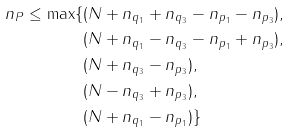Convert formula to latex. <formula><loc_0><loc_0><loc_500><loc_500>n _ { P } \leq \max \{ & ( N + n _ { q _ { 1 } } + n _ { q _ { 3 } } - n _ { p _ { 1 } } - n _ { p _ { 3 } } ) , \\ & ( N + n _ { q _ { 1 } } - n _ { q _ { 3 } } - n _ { p _ { 1 } } + n _ { p _ { 3 } } ) , \\ & ( N + n _ { q _ { 3 } } - n _ { p _ { 3 } } ) , \\ & ( N - n _ { q _ { 3 } } + n _ { p _ { 3 } } ) , \\ & ( N + n _ { q _ { 1 } } - n _ { p _ { 1 } } ) \}</formula> 